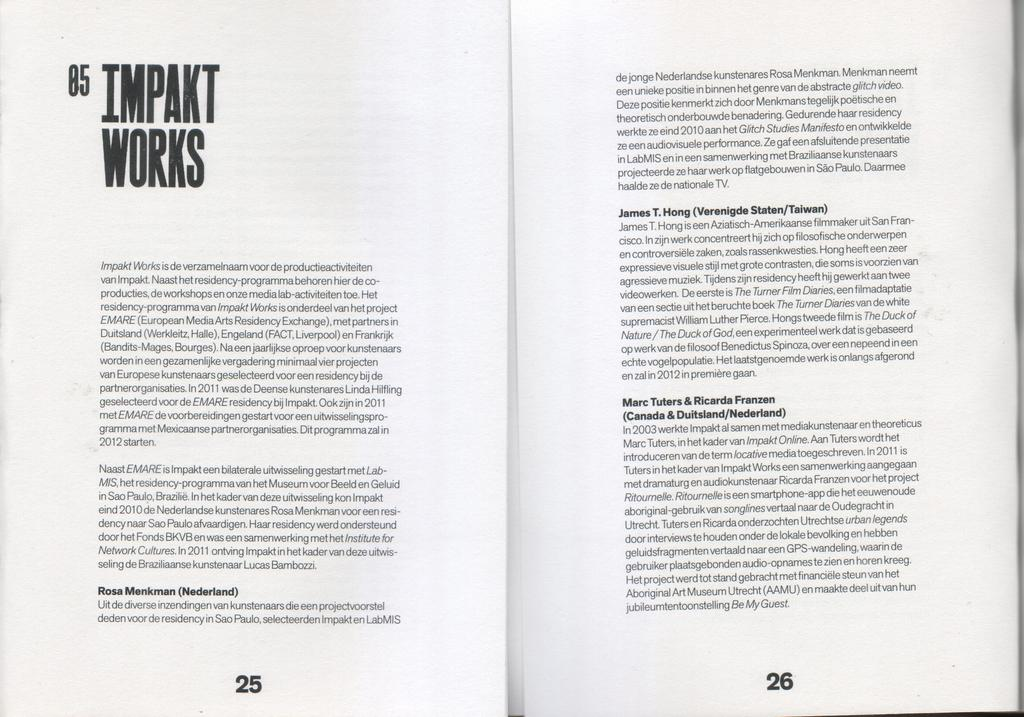<image>
Summarize the visual content of the image. A book is open to page 25 and a chapter called Impakt Works. 